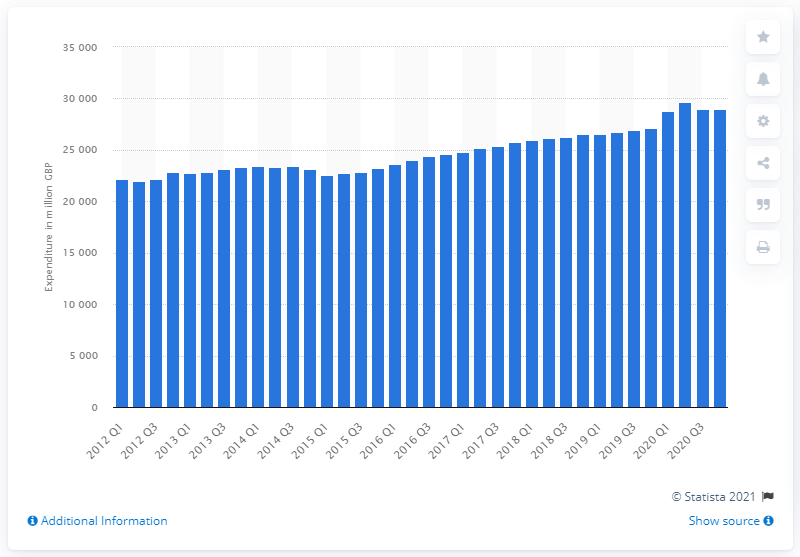List a handful of essential elements in this visual. According to the data, consumer spending for food and non-alcoholic beverages in the fourth quarter of 2020 was 28,955. Household expenditure in the fourth quarter of 2020 was 27,112... 